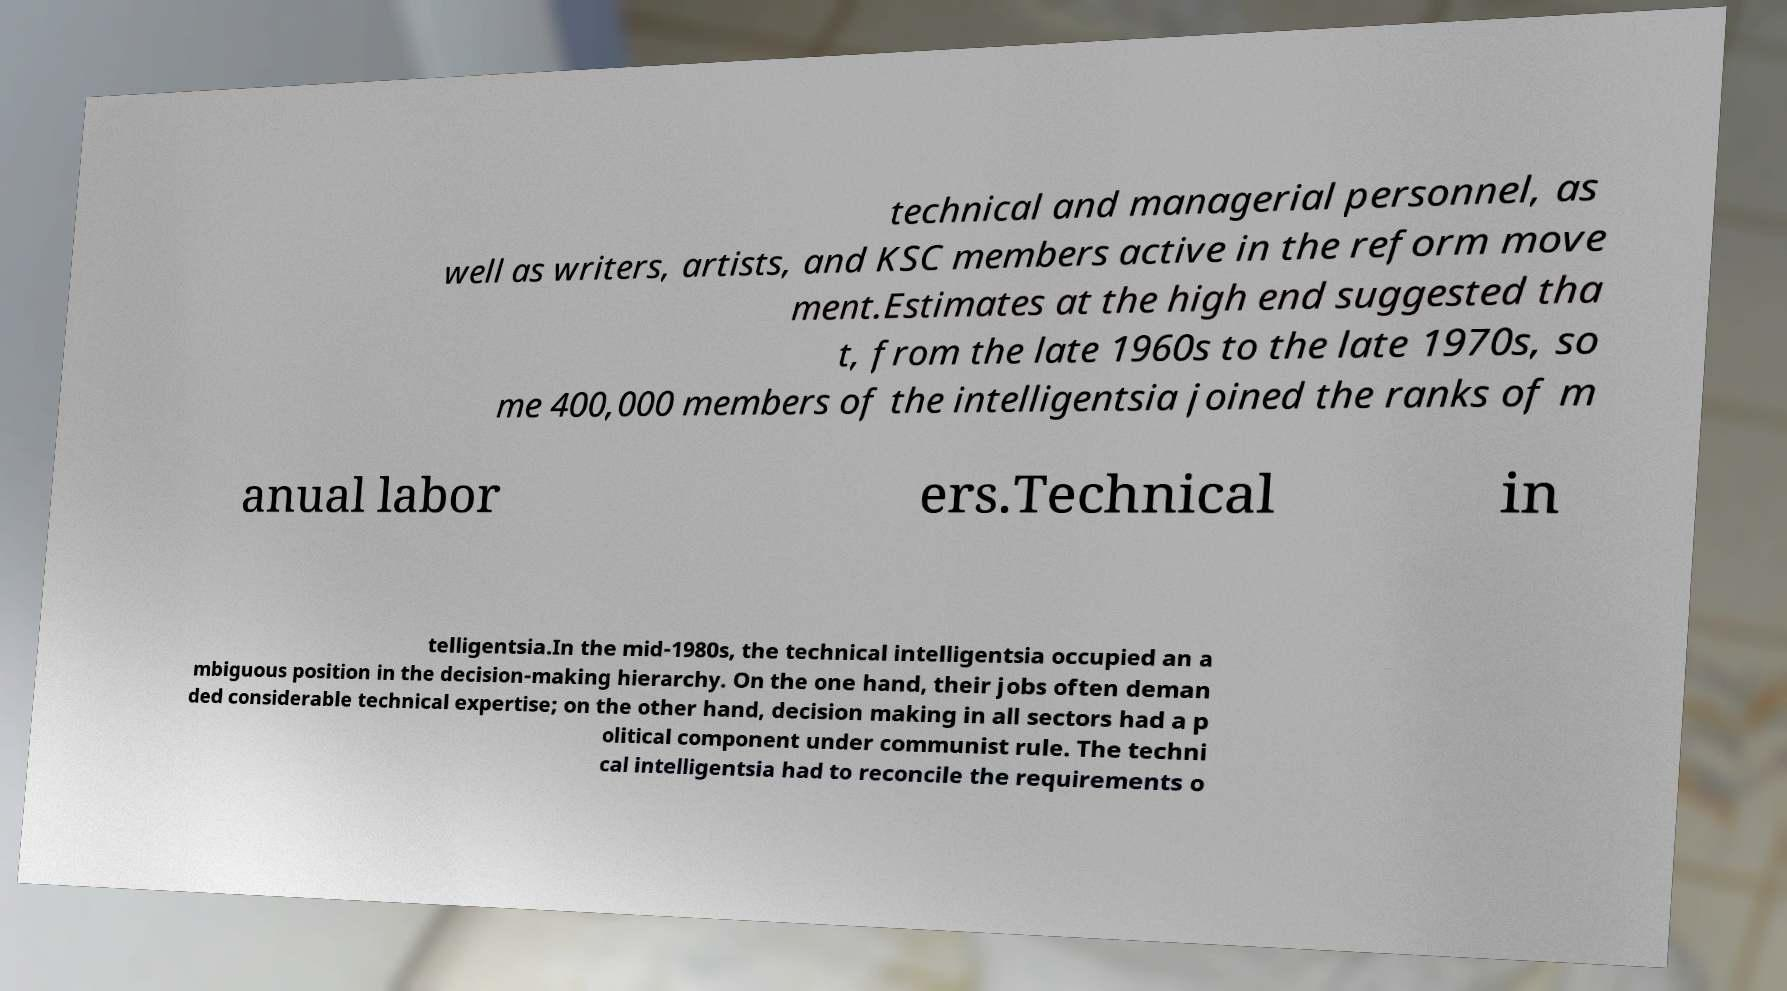What messages or text are displayed in this image? I need them in a readable, typed format. technical and managerial personnel, as well as writers, artists, and KSC members active in the reform move ment.Estimates at the high end suggested tha t, from the late 1960s to the late 1970s, so me 400,000 members of the intelligentsia joined the ranks of m anual labor ers.Technical in telligentsia.In the mid-1980s, the technical intelligentsia occupied an a mbiguous position in the decision-making hierarchy. On the one hand, their jobs often deman ded considerable technical expertise; on the other hand, decision making in all sectors had a p olitical component under communist rule. The techni cal intelligentsia had to reconcile the requirements o 